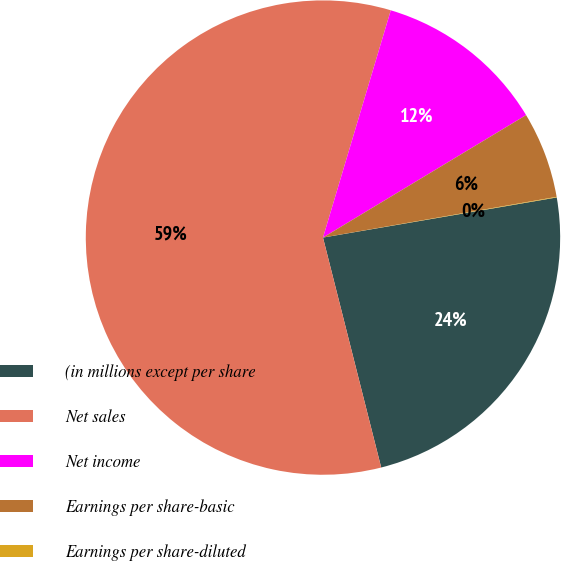Convert chart to OTSL. <chart><loc_0><loc_0><loc_500><loc_500><pie_chart><fcel>(in millions except per share<fcel>Net sales<fcel>Net income<fcel>Earnings per share-basic<fcel>Earnings per share-diluted<nl><fcel>23.76%<fcel>58.56%<fcel>11.75%<fcel>5.89%<fcel>0.04%<nl></chart> 